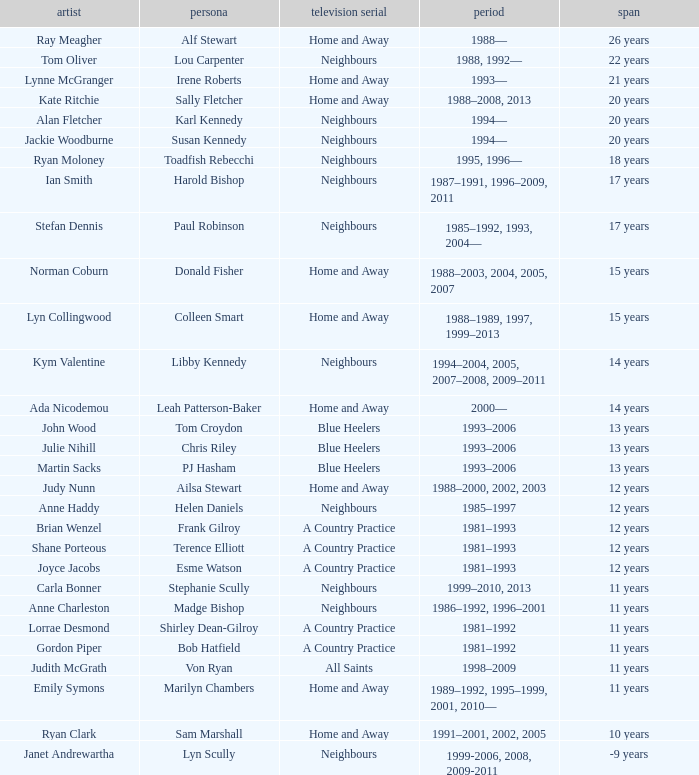How long did Joyce Jacobs portray her character on her show? 12 years. 